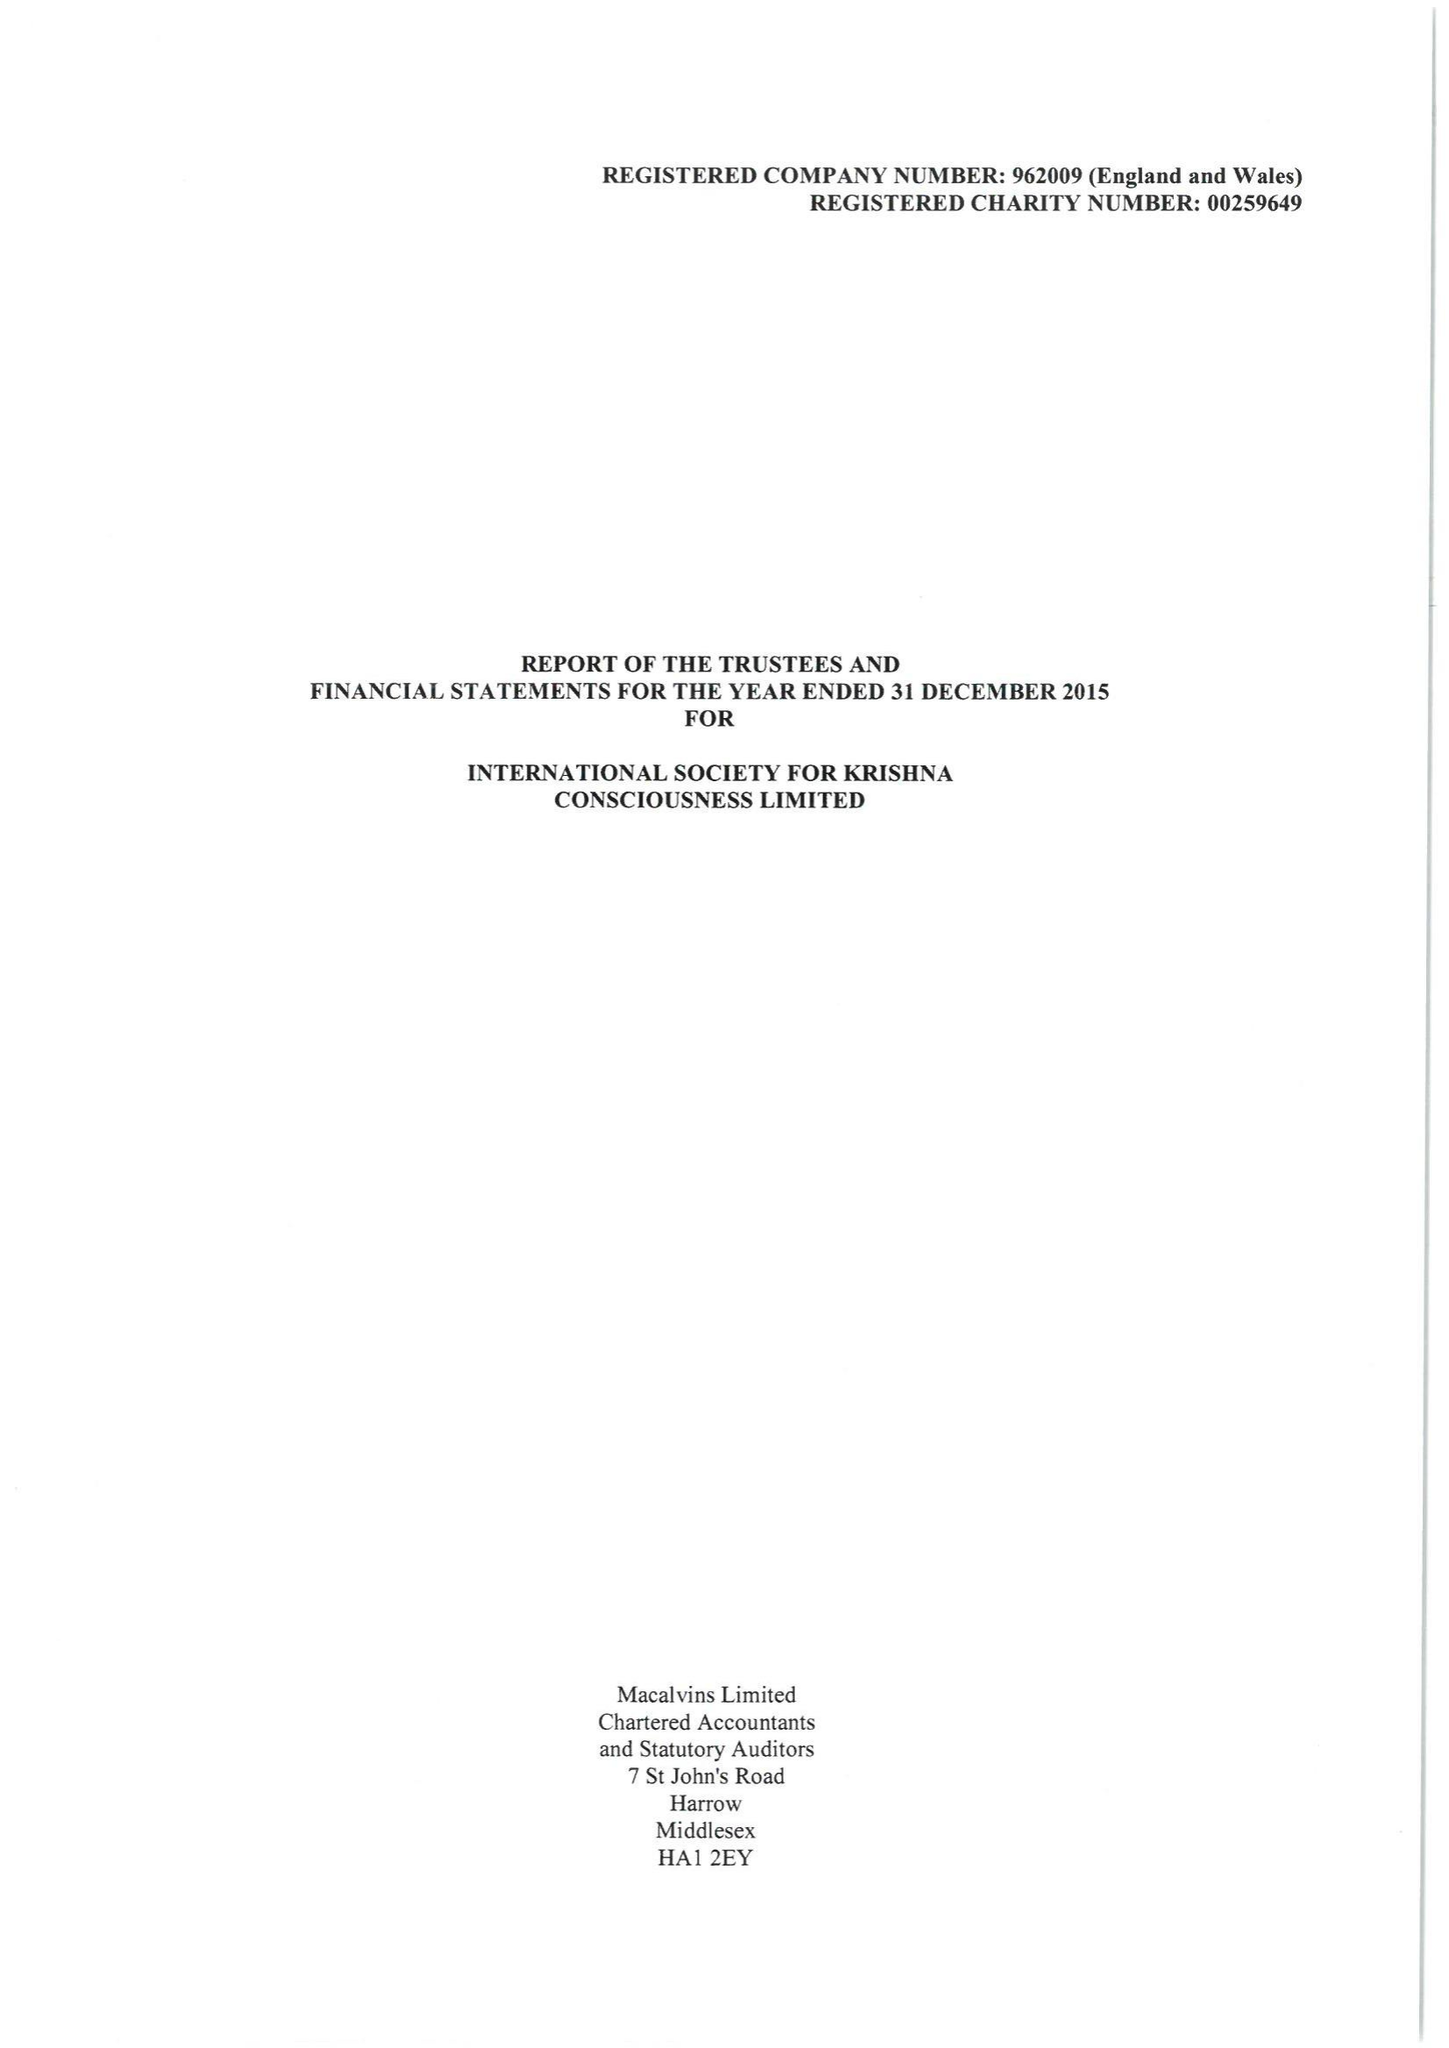What is the value for the charity_name?
Answer the question using a single word or phrase. International Society For Krishna Consciousness Ltd. 